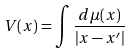Convert formula to latex. <formula><loc_0><loc_0><loc_500><loc_500>V ( x ) = \int \frac { d \mu ( x ) } { | x - x ^ { \prime } | }</formula> 